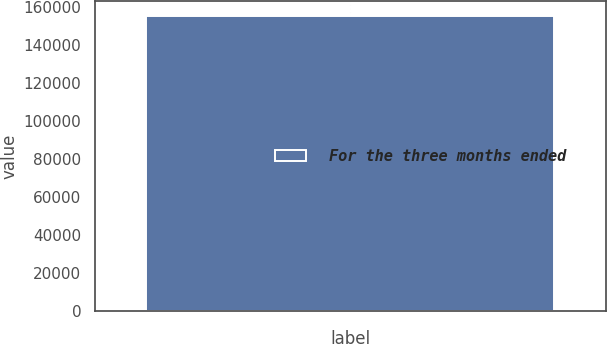Convert chart to OTSL. <chart><loc_0><loc_0><loc_500><loc_500><bar_chart><fcel>For the three months ended<nl><fcel>155198<nl></chart> 